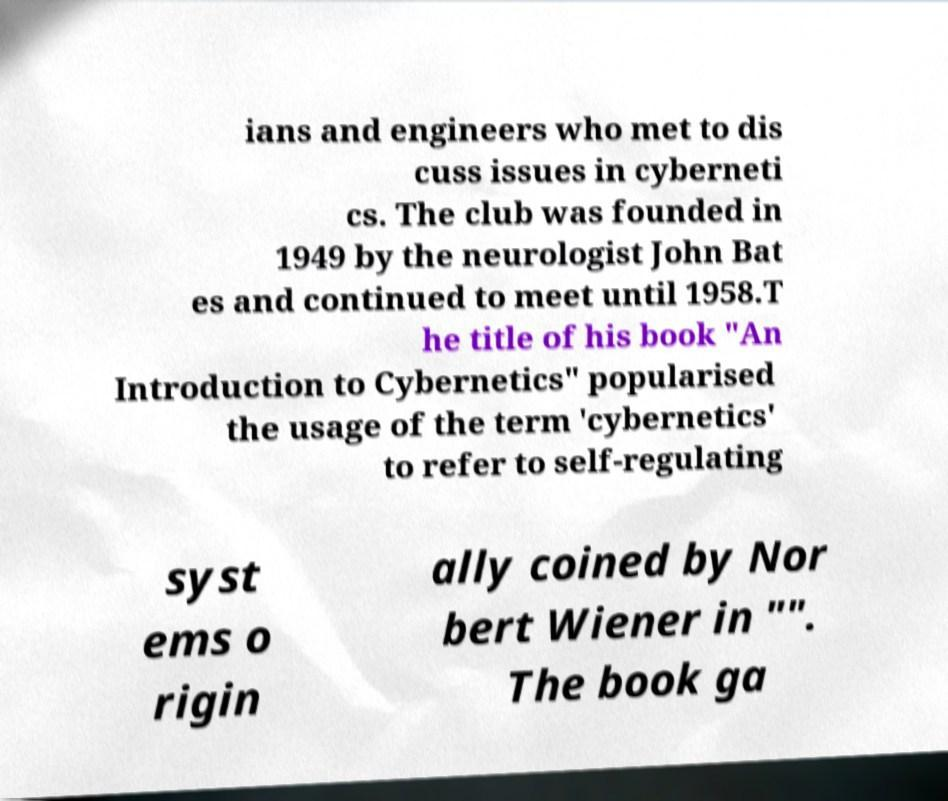What messages or text are displayed in this image? I need them in a readable, typed format. ians and engineers who met to dis cuss issues in cyberneti cs. The club was founded in 1949 by the neurologist John Bat es and continued to meet until 1958.T he title of his book "An Introduction to Cybernetics" popularised the usage of the term 'cybernetics' to refer to self-regulating syst ems o rigin ally coined by Nor bert Wiener in "". The book ga 